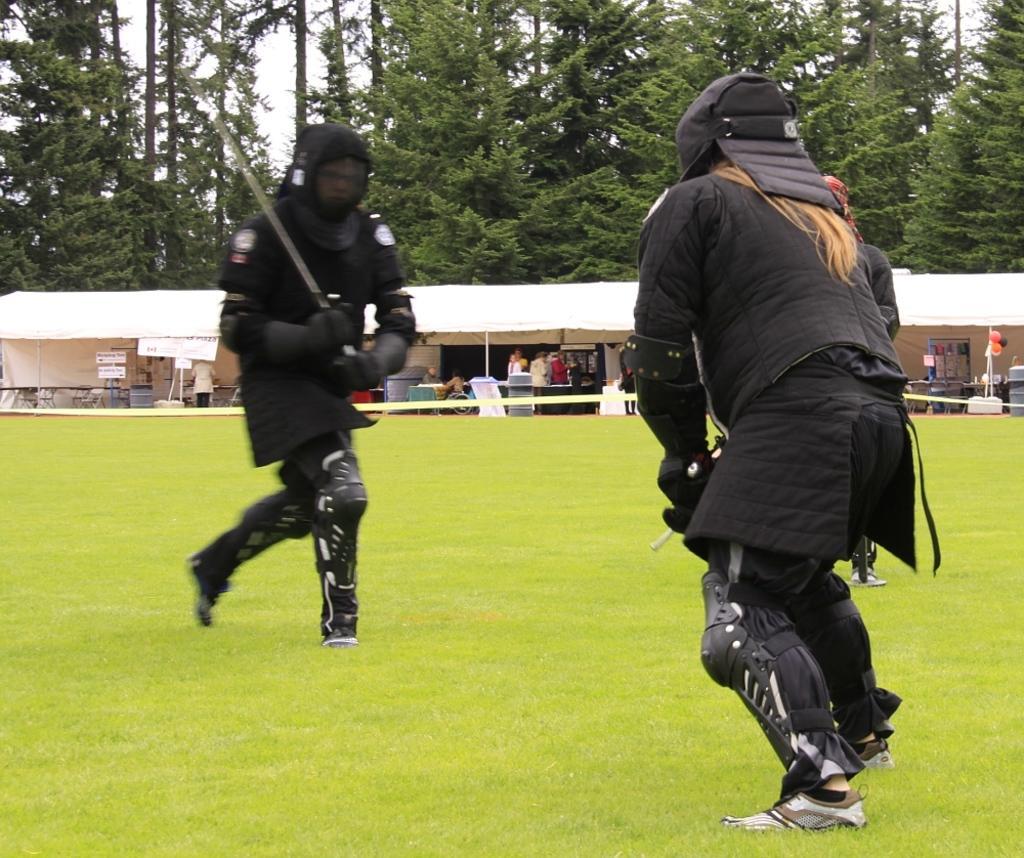In one or two sentences, can you explain what this image depicts? In this image we can see one white tent with poles, some chairs, some tables, some objects on the tables, some objects on the ground, some boards with text, one blackboard, one ribbon, two persons sitting near the table, some people are standing, two persons in black dress sword play with knife on the ground, some trees in the background, some grass on the ground, some objects attached to the board, some balloons with pole, one table with tablecloth and in the background there is the sky. 